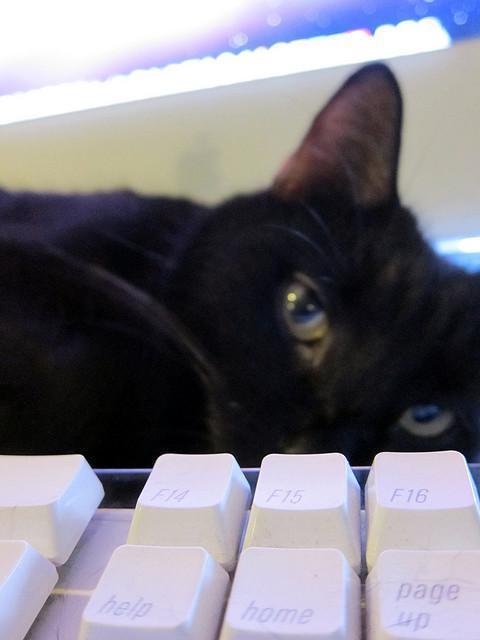How many people are in the picture?
Give a very brief answer. 0. 